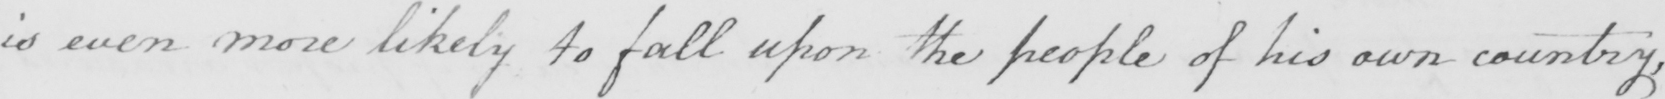What text is written in this handwritten line? is even more likely to fall upon the people of his own country , 